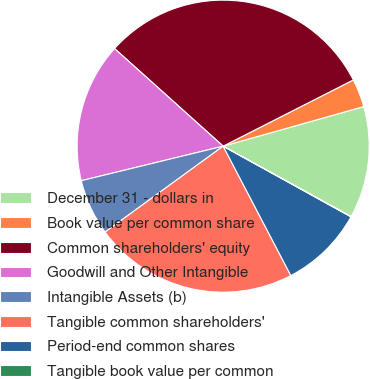Convert chart to OTSL. <chart><loc_0><loc_0><loc_500><loc_500><pie_chart><fcel>December 31 - dollars in<fcel>Book value per common share<fcel>Common shareholders' equity<fcel>Goodwill and Other Intangible<fcel>Intangible Assets (b)<fcel>Tangible common shareholders'<fcel>Period-end common shares<fcel>Tangible book value per common<nl><fcel>12.37%<fcel>3.12%<fcel>30.86%<fcel>15.45%<fcel>6.21%<fcel>22.66%<fcel>9.29%<fcel>0.04%<nl></chart> 